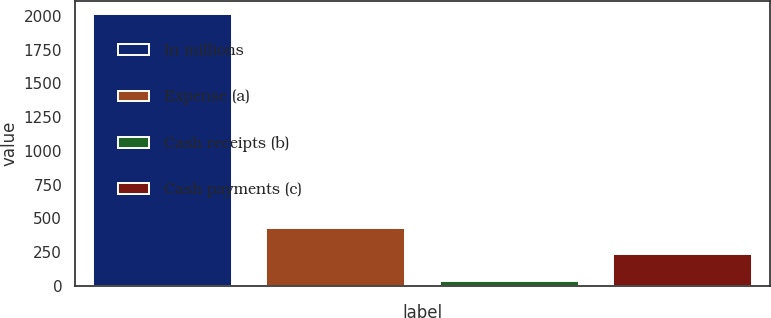Convert chart. <chart><loc_0><loc_0><loc_500><loc_500><bar_chart><fcel>In millions<fcel>Expense (a)<fcel>Cash receipts (b)<fcel>Cash payments (c)<nl><fcel>2012<fcel>431.2<fcel>36<fcel>233.6<nl></chart> 